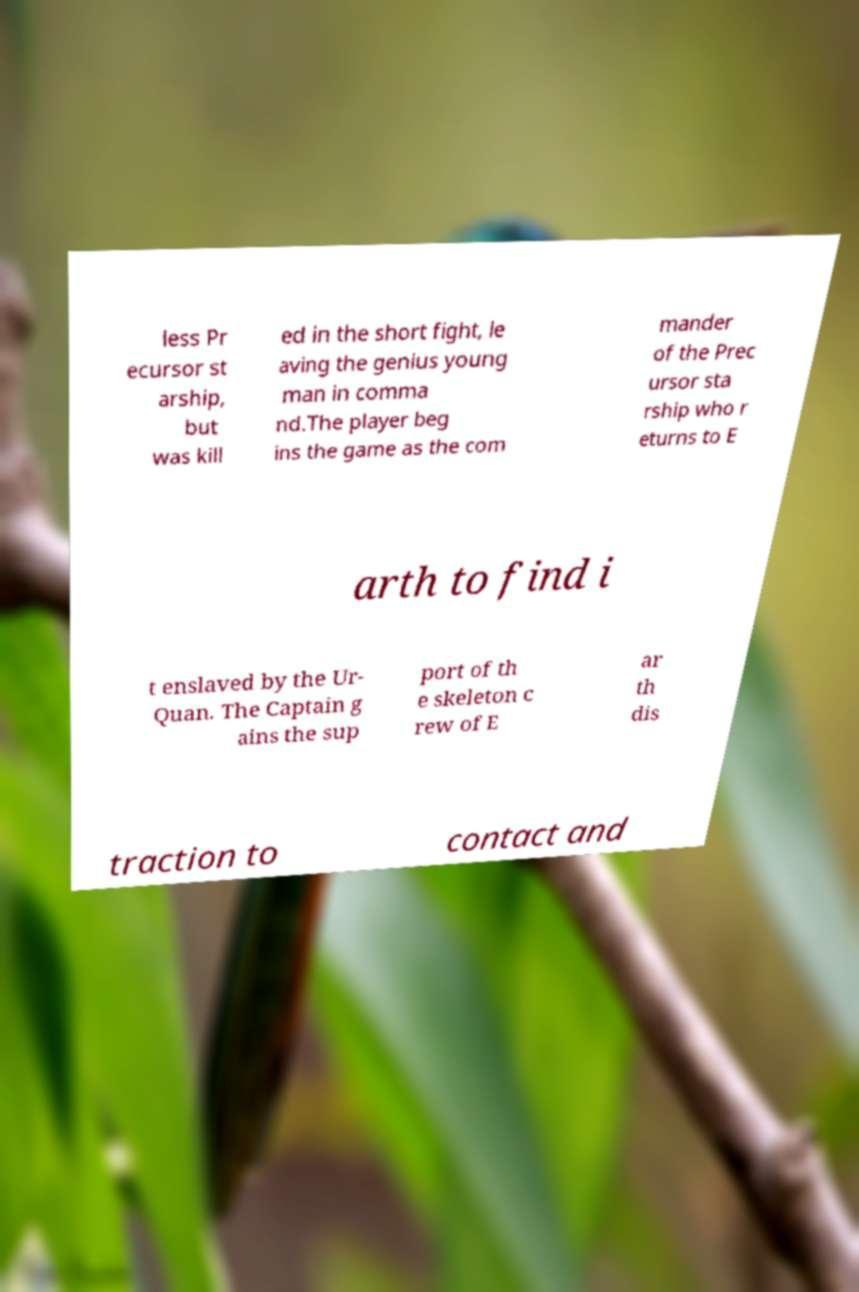Could you extract and type out the text from this image? less Pr ecursor st arship, but was kill ed in the short fight, le aving the genius young man in comma nd.The player beg ins the game as the com mander of the Prec ursor sta rship who r eturns to E arth to find i t enslaved by the Ur- Quan. The Captain g ains the sup port of th e skeleton c rew of E ar th dis traction to contact and 